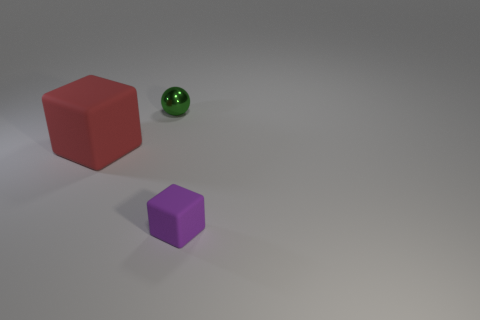What number of small objects are the same color as the small matte block?
Ensure brevity in your answer.  0. Do the thing to the left of the metallic sphere and the rubber object that is to the right of the red object have the same shape?
Ensure brevity in your answer.  Yes. What color is the cube in front of the red thing behind the tiny object in front of the tiny green metal sphere?
Ensure brevity in your answer.  Purple. What is the color of the object that is to the right of the green sphere?
Your answer should be very brief. Purple. There is a metal object that is the same size as the purple matte object; what is its color?
Your response must be concise. Green. Do the purple cube and the green metal sphere have the same size?
Your answer should be very brief. Yes. What number of objects are behind the big red matte cube?
Your answer should be very brief. 1. What number of objects are cubes right of the green metallic sphere or tiny blocks?
Ensure brevity in your answer.  1. Is the number of rubber cubes behind the green metallic thing greater than the number of big red blocks to the left of the large cube?
Provide a short and direct response. No. There is a red object; is it the same size as the green metallic object that is behind the small purple object?
Your answer should be very brief. No. 